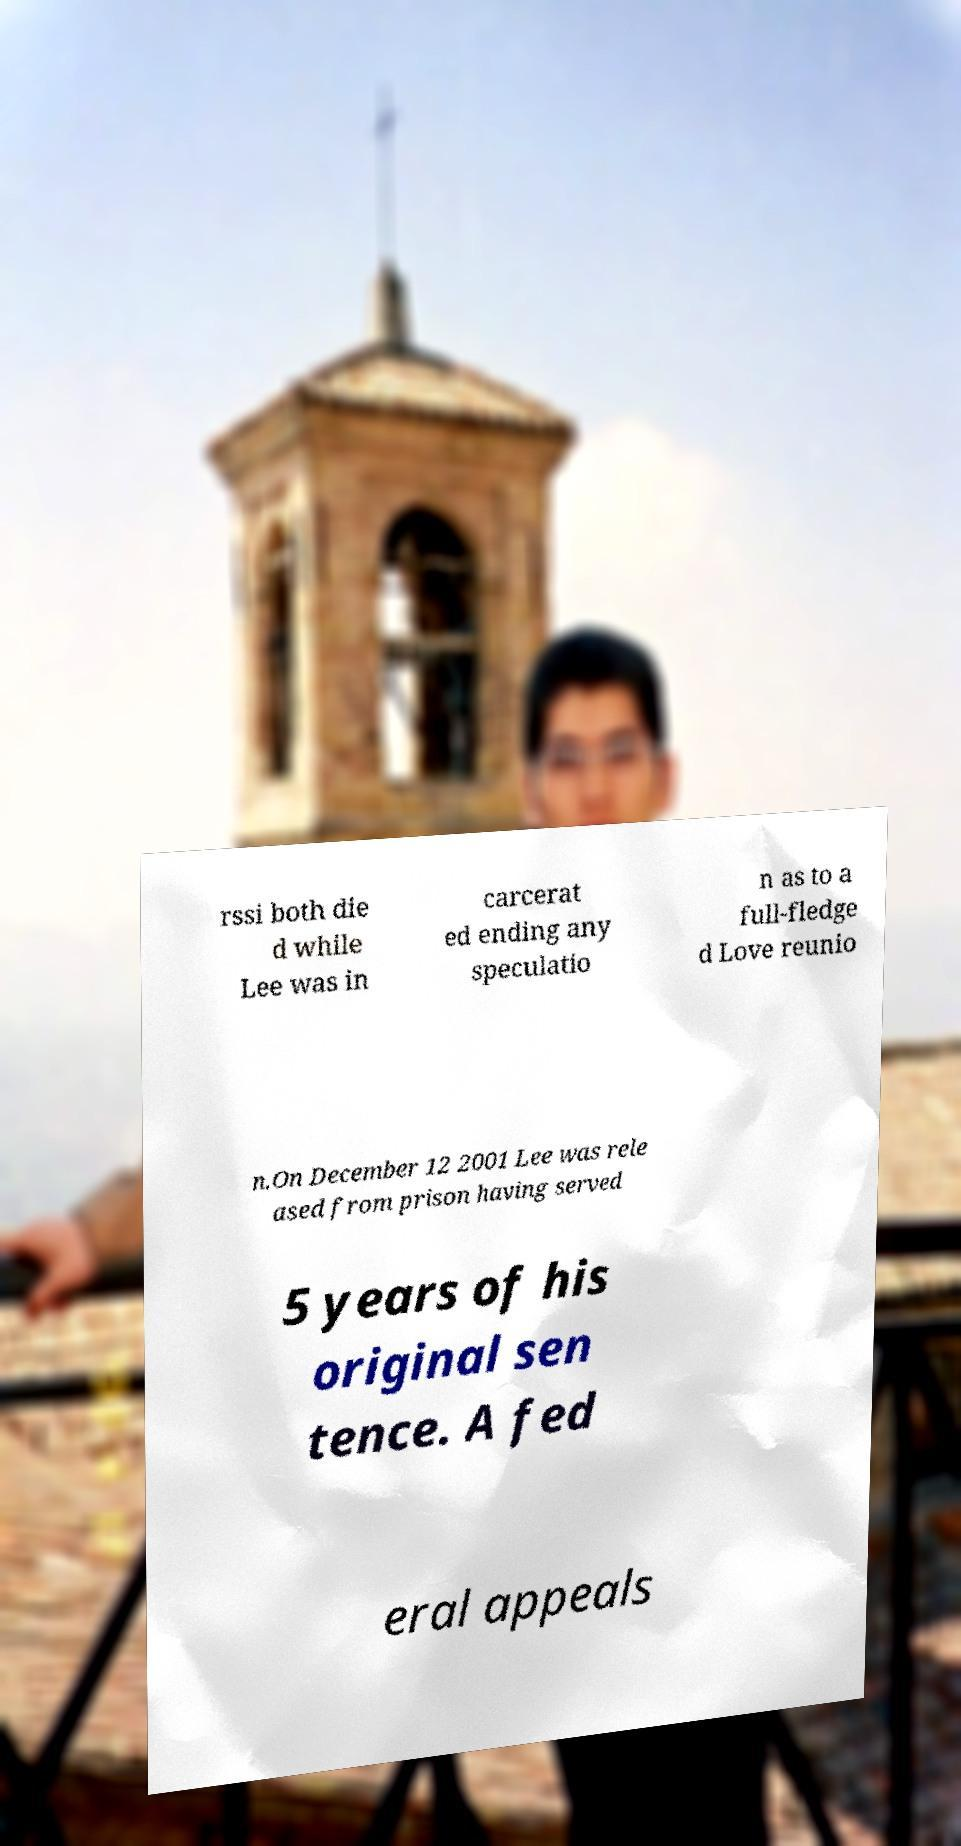Can you accurately transcribe the text from the provided image for me? rssi both die d while Lee was in carcerat ed ending any speculatio n as to a full-fledge d Love reunio n.On December 12 2001 Lee was rele ased from prison having served 5 years of his original sen tence. A fed eral appeals 